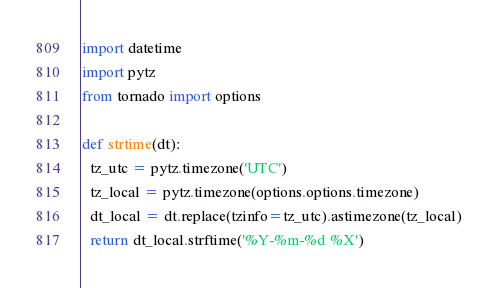<code> <loc_0><loc_0><loc_500><loc_500><_Python_>import datetime
import pytz
from tornado import options

def strtime(dt):
  tz_utc = pytz.timezone('UTC')
  tz_local = pytz.timezone(options.options.timezone)
  dt_local = dt.replace(tzinfo=tz_utc).astimezone(tz_local)
  return dt_local.strftime('%Y-%m-%d %X')

</code> 